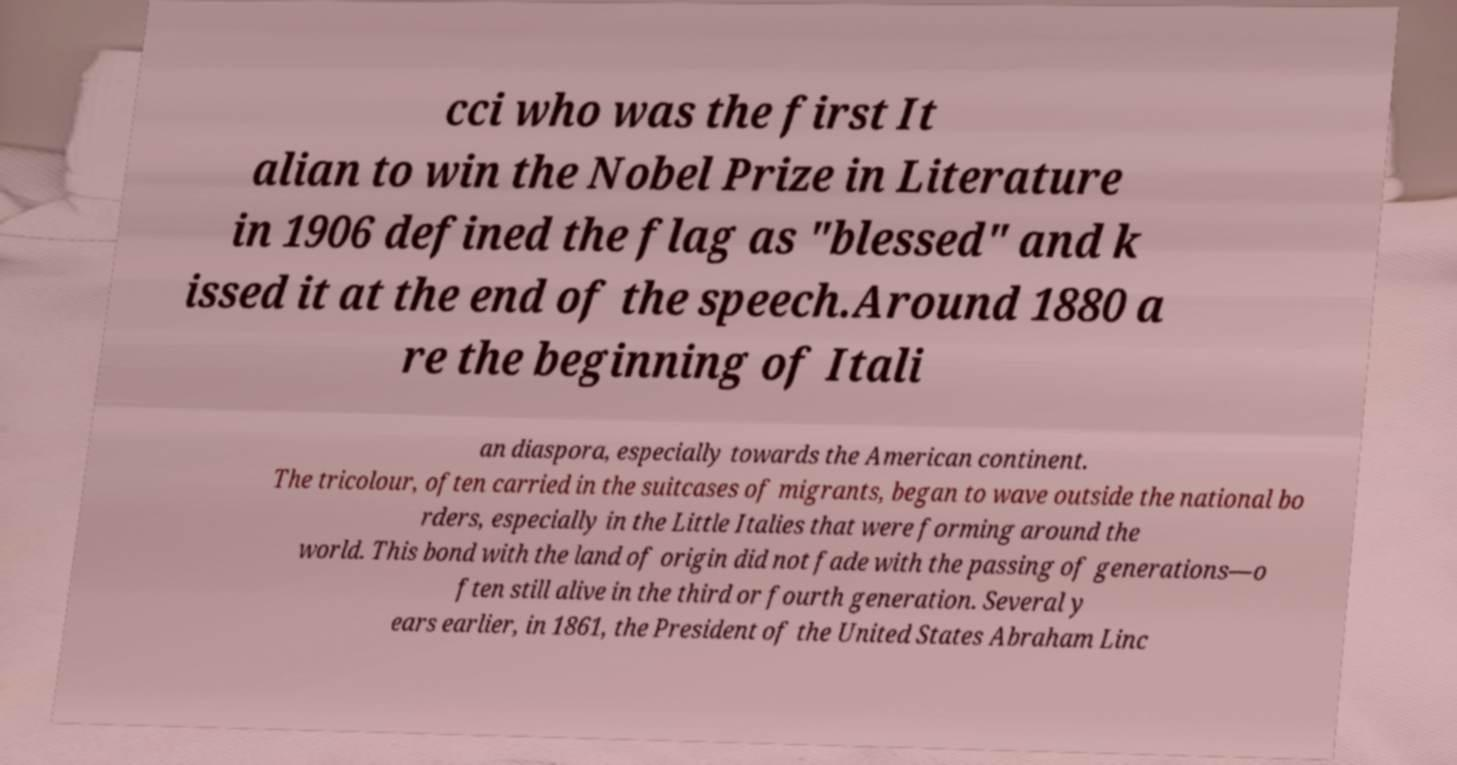Please identify and transcribe the text found in this image. cci who was the first It alian to win the Nobel Prize in Literature in 1906 defined the flag as "blessed" and k issed it at the end of the speech.Around 1880 a re the beginning of Itali an diaspora, especially towards the American continent. The tricolour, often carried in the suitcases of migrants, began to wave outside the national bo rders, especially in the Little Italies that were forming around the world. This bond with the land of origin did not fade with the passing of generations—o ften still alive in the third or fourth generation. Several y ears earlier, in 1861, the President of the United States Abraham Linc 